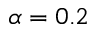<formula> <loc_0><loc_0><loc_500><loc_500>\alpha = 0 . 2</formula> 